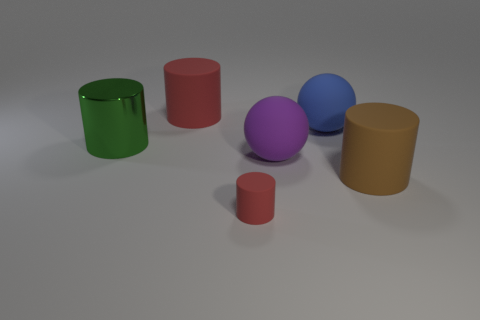Subtract all cyan cylinders. Subtract all blue spheres. How many cylinders are left? 4 Add 4 large gray balls. How many objects exist? 10 Subtract all spheres. How many objects are left? 4 Add 4 large blue matte objects. How many large blue matte objects are left? 5 Add 5 green metallic things. How many green metallic things exist? 6 Subtract 0 green cubes. How many objects are left? 6 Subtract all big red rubber things. Subtract all tiny red cylinders. How many objects are left? 4 